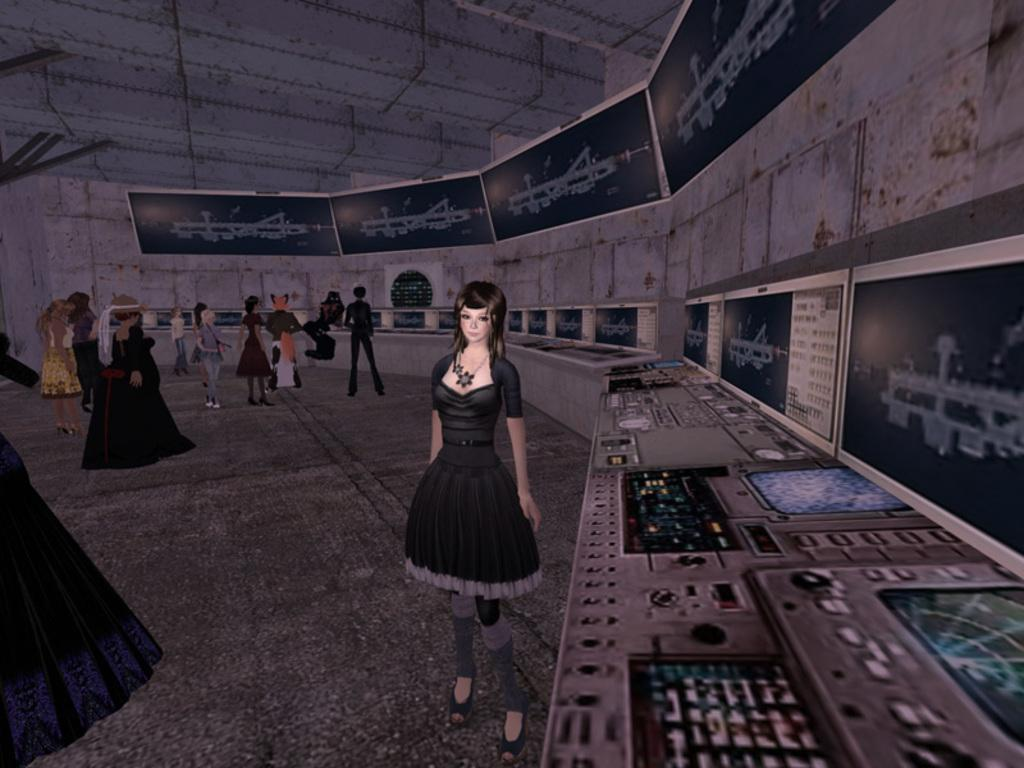What type of image is being described? The image is edited and animated. What can be seen in the image? There are persons in the image. Where are the screens located in the image? The screens are on the right side of the image. How many cakes are being held by the woman in the image? There is no woman present in the image, nor are there any cakes. 